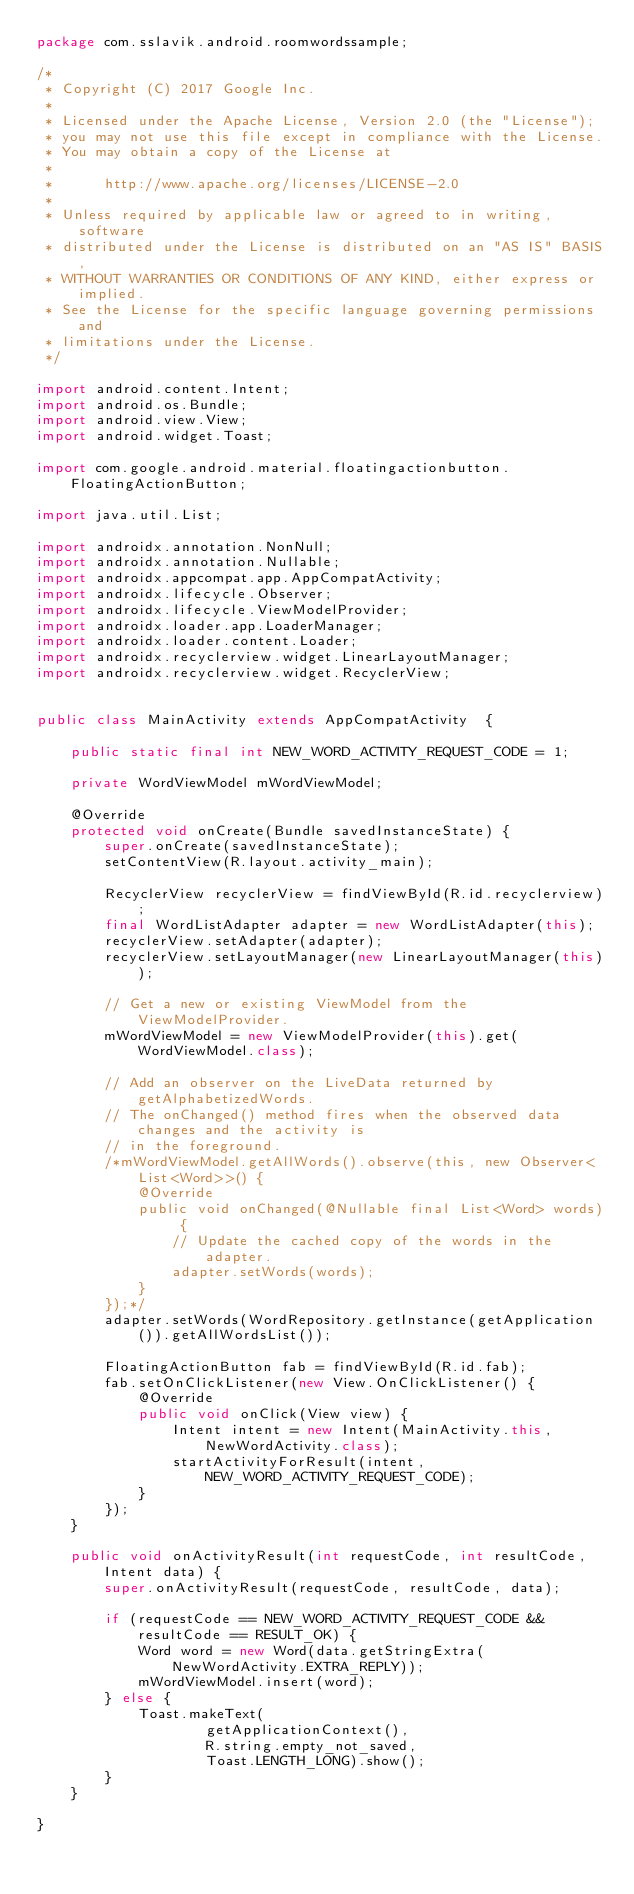Convert code to text. <code><loc_0><loc_0><loc_500><loc_500><_Java_>package com.sslavik.android.roomwordssample;

/*
 * Copyright (C) 2017 Google Inc.
 *
 * Licensed under the Apache License, Version 2.0 (the "License");
 * you may not use this file except in compliance with the License.
 * You may obtain a copy of the License at
 *
 *      http://www.apache.org/licenses/LICENSE-2.0
 *
 * Unless required by applicable law or agreed to in writing, software
 * distributed under the License is distributed on an "AS IS" BASIS,
 * WITHOUT WARRANTIES OR CONDITIONS OF ANY KIND, either express or implied.
 * See the License for the specific language governing permissions and
 * limitations under the License.
 */

import android.content.Intent;
import android.os.Bundle;
import android.view.View;
import android.widget.Toast;

import com.google.android.material.floatingactionbutton.FloatingActionButton;

import java.util.List;

import androidx.annotation.NonNull;
import androidx.annotation.Nullable;
import androidx.appcompat.app.AppCompatActivity;
import androidx.lifecycle.Observer;
import androidx.lifecycle.ViewModelProvider;
import androidx.loader.app.LoaderManager;
import androidx.loader.content.Loader;
import androidx.recyclerview.widget.LinearLayoutManager;
import androidx.recyclerview.widget.RecyclerView;


public class MainActivity extends AppCompatActivity  {

    public static final int NEW_WORD_ACTIVITY_REQUEST_CODE = 1;

    private WordViewModel mWordViewModel;

    @Override
    protected void onCreate(Bundle savedInstanceState) {
        super.onCreate(savedInstanceState);
        setContentView(R.layout.activity_main);

        RecyclerView recyclerView = findViewById(R.id.recyclerview);
        final WordListAdapter adapter = new WordListAdapter(this);
        recyclerView.setAdapter(adapter);
        recyclerView.setLayoutManager(new LinearLayoutManager(this));

        // Get a new or existing ViewModel from the ViewModelProvider.
        mWordViewModel = new ViewModelProvider(this).get(WordViewModel.class);

        // Add an observer on the LiveData returned by getAlphabetizedWords.
        // The onChanged() method fires when the observed data changes and the activity is
        // in the foreground.
        /*mWordViewModel.getAllWords().observe(this, new Observer<List<Word>>() {
            @Override
            public void onChanged(@Nullable final List<Word> words) {
                // Update the cached copy of the words in the adapter.
                adapter.setWords(words);
            }
        });*/
        adapter.setWords(WordRepository.getInstance(getApplication()).getAllWordsList());

        FloatingActionButton fab = findViewById(R.id.fab);
        fab.setOnClickListener(new View.OnClickListener() {
            @Override
            public void onClick(View view) {
                Intent intent = new Intent(MainActivity.this, NewWordActivity.class);
                startActivityForResult(intent, NEW_WORD_ACTIVITY_REQUEST_CODE);
            }
        });
    }

    public void onActivityResult(int requestCode, int resultCode, Intent data) {
        super.onActivityResult(requestCode, resultCode, data);

        if (requestCode == NEW_WORD_ACTIVITY_REQUEST_CODE && resultCode == RESULT_OK) {
            Word word = new Word(data.getStringExtra(NewWordActivity.EXTRA_REPLY));
            mWordViewModel.insert(word);
        } else {
            Toast.makeText(
                    getApplicationContext(),
                    R.string.empty_not_saved,
                    Toast.LENGTH_LONG).show();
        }
    }

}
</code> 